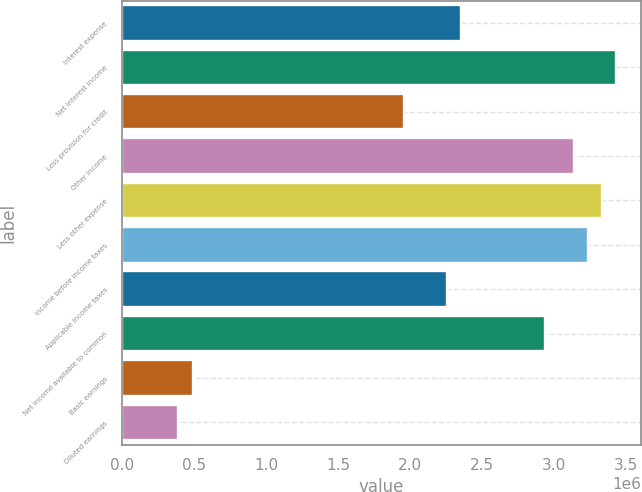<chart> <loc_0><loc_0><loc_500><loc_500><bar_chart><fcel>Interest expense<fcel>Net interest income<fcel>Less provision for credit<fcel>Other income<fcel>Less other expense<fcel>Income before income taxes<fcel>Applicable income taxes<fcel>Net income available to common<fcel>Basic earnings<fcel>Diluted earnings<nl><fcel>2.35278e+06<fcel>3.43114e+06<fcel>1.96065e+06<fcel>3.13704e+06<fcel>3.33311e+06<fcel>3.23507e+06<fcel>2.25475e+06<fcel>2.94098e+06<fcel>490163<fcel>392131<nl></chart> 